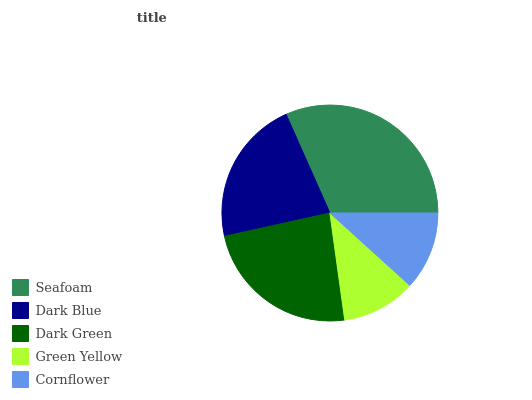Is Green Yellow the minimum?
Answer yes or no. Yes. Is Seafoam the maximum?
Answer yes or no. Yes. Is Dark Blue the minimum?
Answer yes or no. No. Is Dark Blue the maximum?
Answer yes or no. No. Is Seafoam greater than Dark Blue?
Answer yes or no. Yes. Is Dark Blue less than Seafoam?
Answer yes or no. Yes. Is Dark Blue greater than Seafoam?
Answer yes or no. No. Is Seafoam less than Dark Blue?
Answer yes or no. No. Is Dark Blue the high median?
Answer yes or no. Yes. Is Dark Blue the low median?
Answer yes or no. Yes. Is Seafoam the high median?
Answer yes or no. No. Is Cornflower the low median?
Answer yes or no. No. 